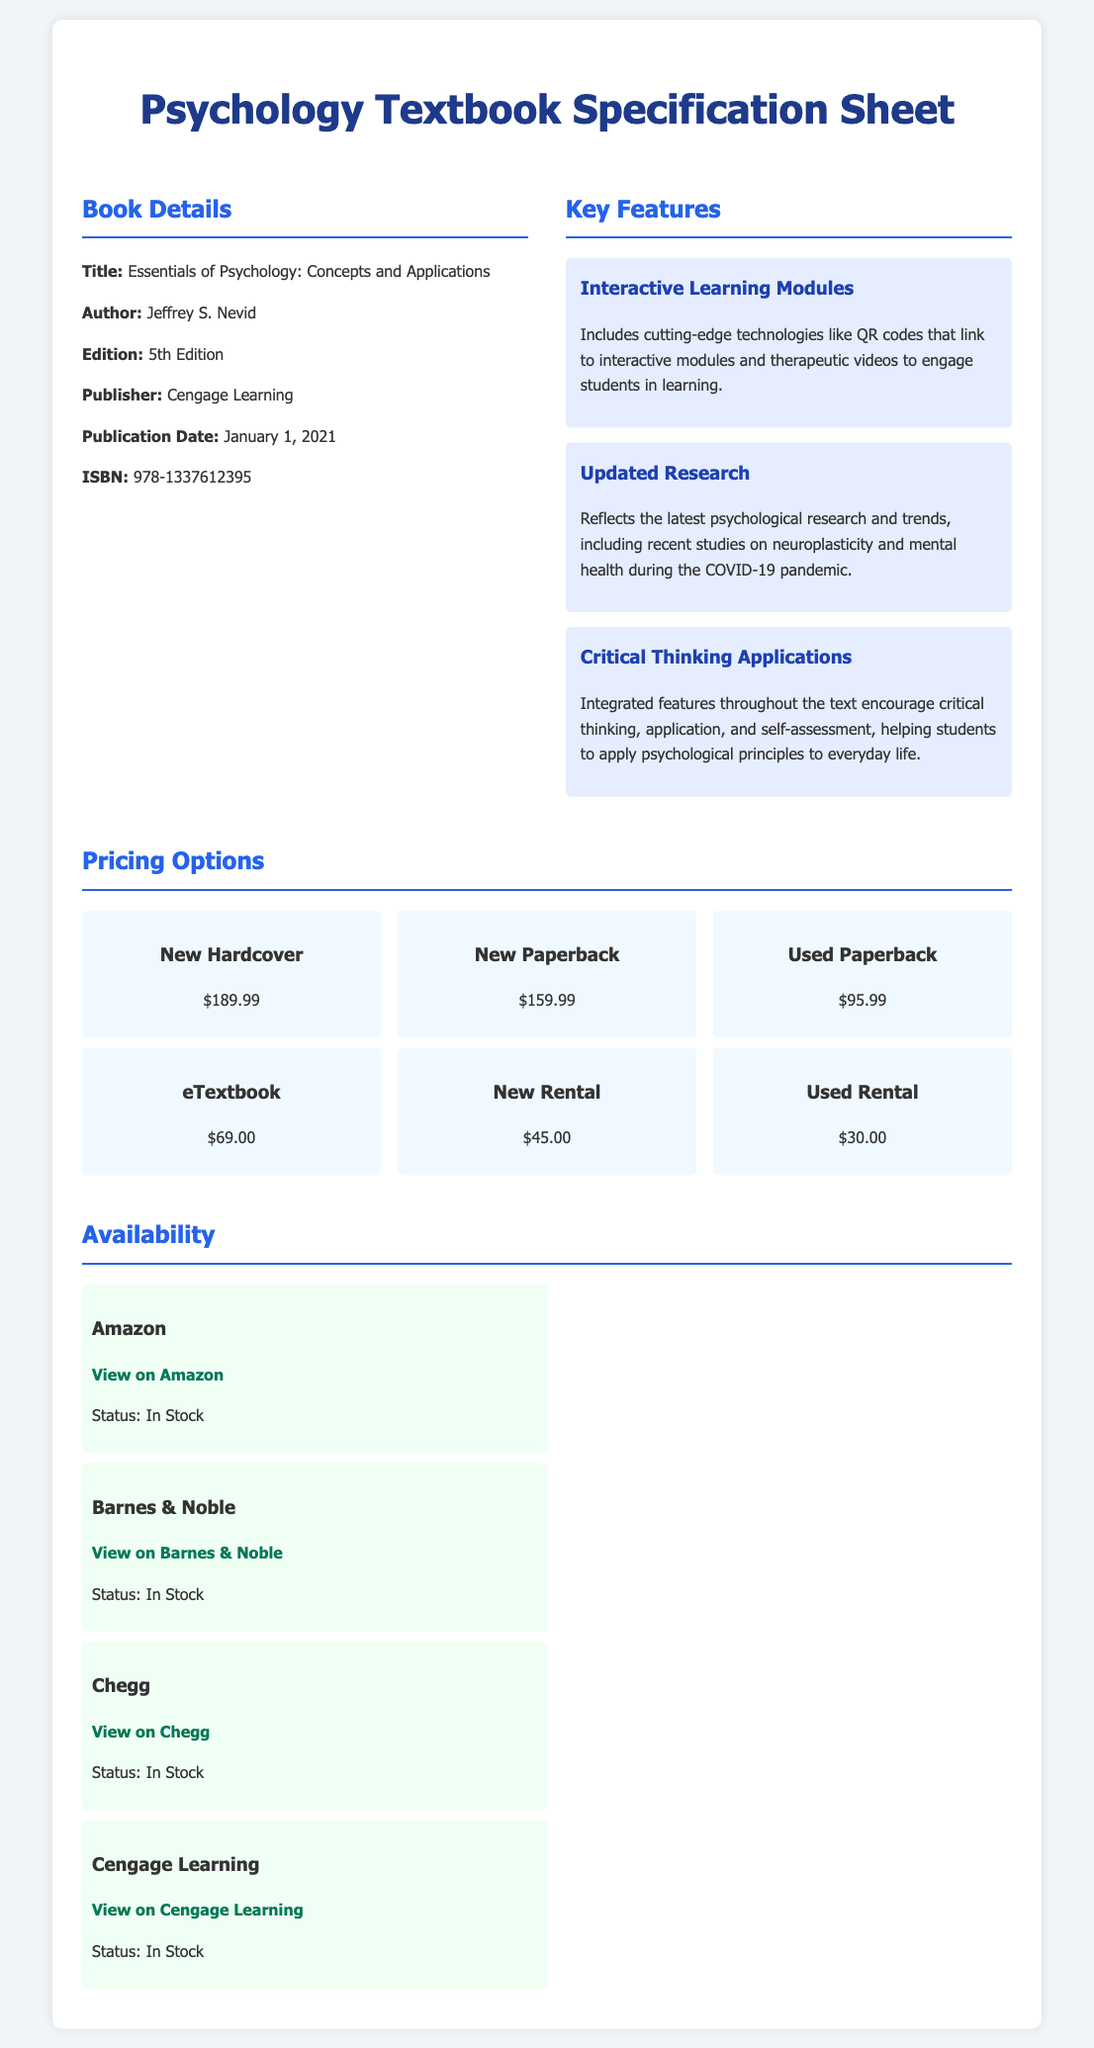What is the title of the textbook? The title is specifically mentioned under the Book Details section of the document.
Answer: Essentials of Psychology: Concepts and Applications Who is the author of the textbook? The author's name is provided in the Book Details section of the document.
Answer: Jeffrey S. Nevid What is the publication date of the textbook? The publication date is clearly specified in the Book Details section of the document.
Answer: January 1, 2021 What is the price of a new hardcover copy? The price for a new hardcover is listed in the Pricing Options section of the document.
Answer: $189.99 Which retailer has a link to view the textbook? Several retailers have links provided, listed under the Availability section of the document.
Answer: Amazon How many key features are listed for the textbook? The document mentions multiple key features in the Key Features section.
Answer: Three What is the ISBN of the textbook? The ISBN is explicitly mentioned in the Book Details section of the document.
Answer: 978-1337612395 What is the price of the eTextbook? The price for the eTextbook is provided in the Pricing Options section.
Answer: $69.00 What type of textbook options is listed for rental? The document includes different rental options mentioned in the Pricing Options section.
Answer: New Rental and Used Rental 